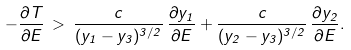<formula> <loc_0><loc_0><loc_500><loc_500>- \frac { \partial T } { \partial E } \, > \, \frac { c } { ( y _ { 1 } - y _ { 3 } ) ^ { 3 / 2 } } \, \frac { \partial y _ { 1 } } { \partial E } + \frac { c } { ( y _ { 2 } - y _ { 3 } ) ^ { 3 / 2 } } \, \frac { \partial y _ { 2 } } { \partial E } .</formula> 